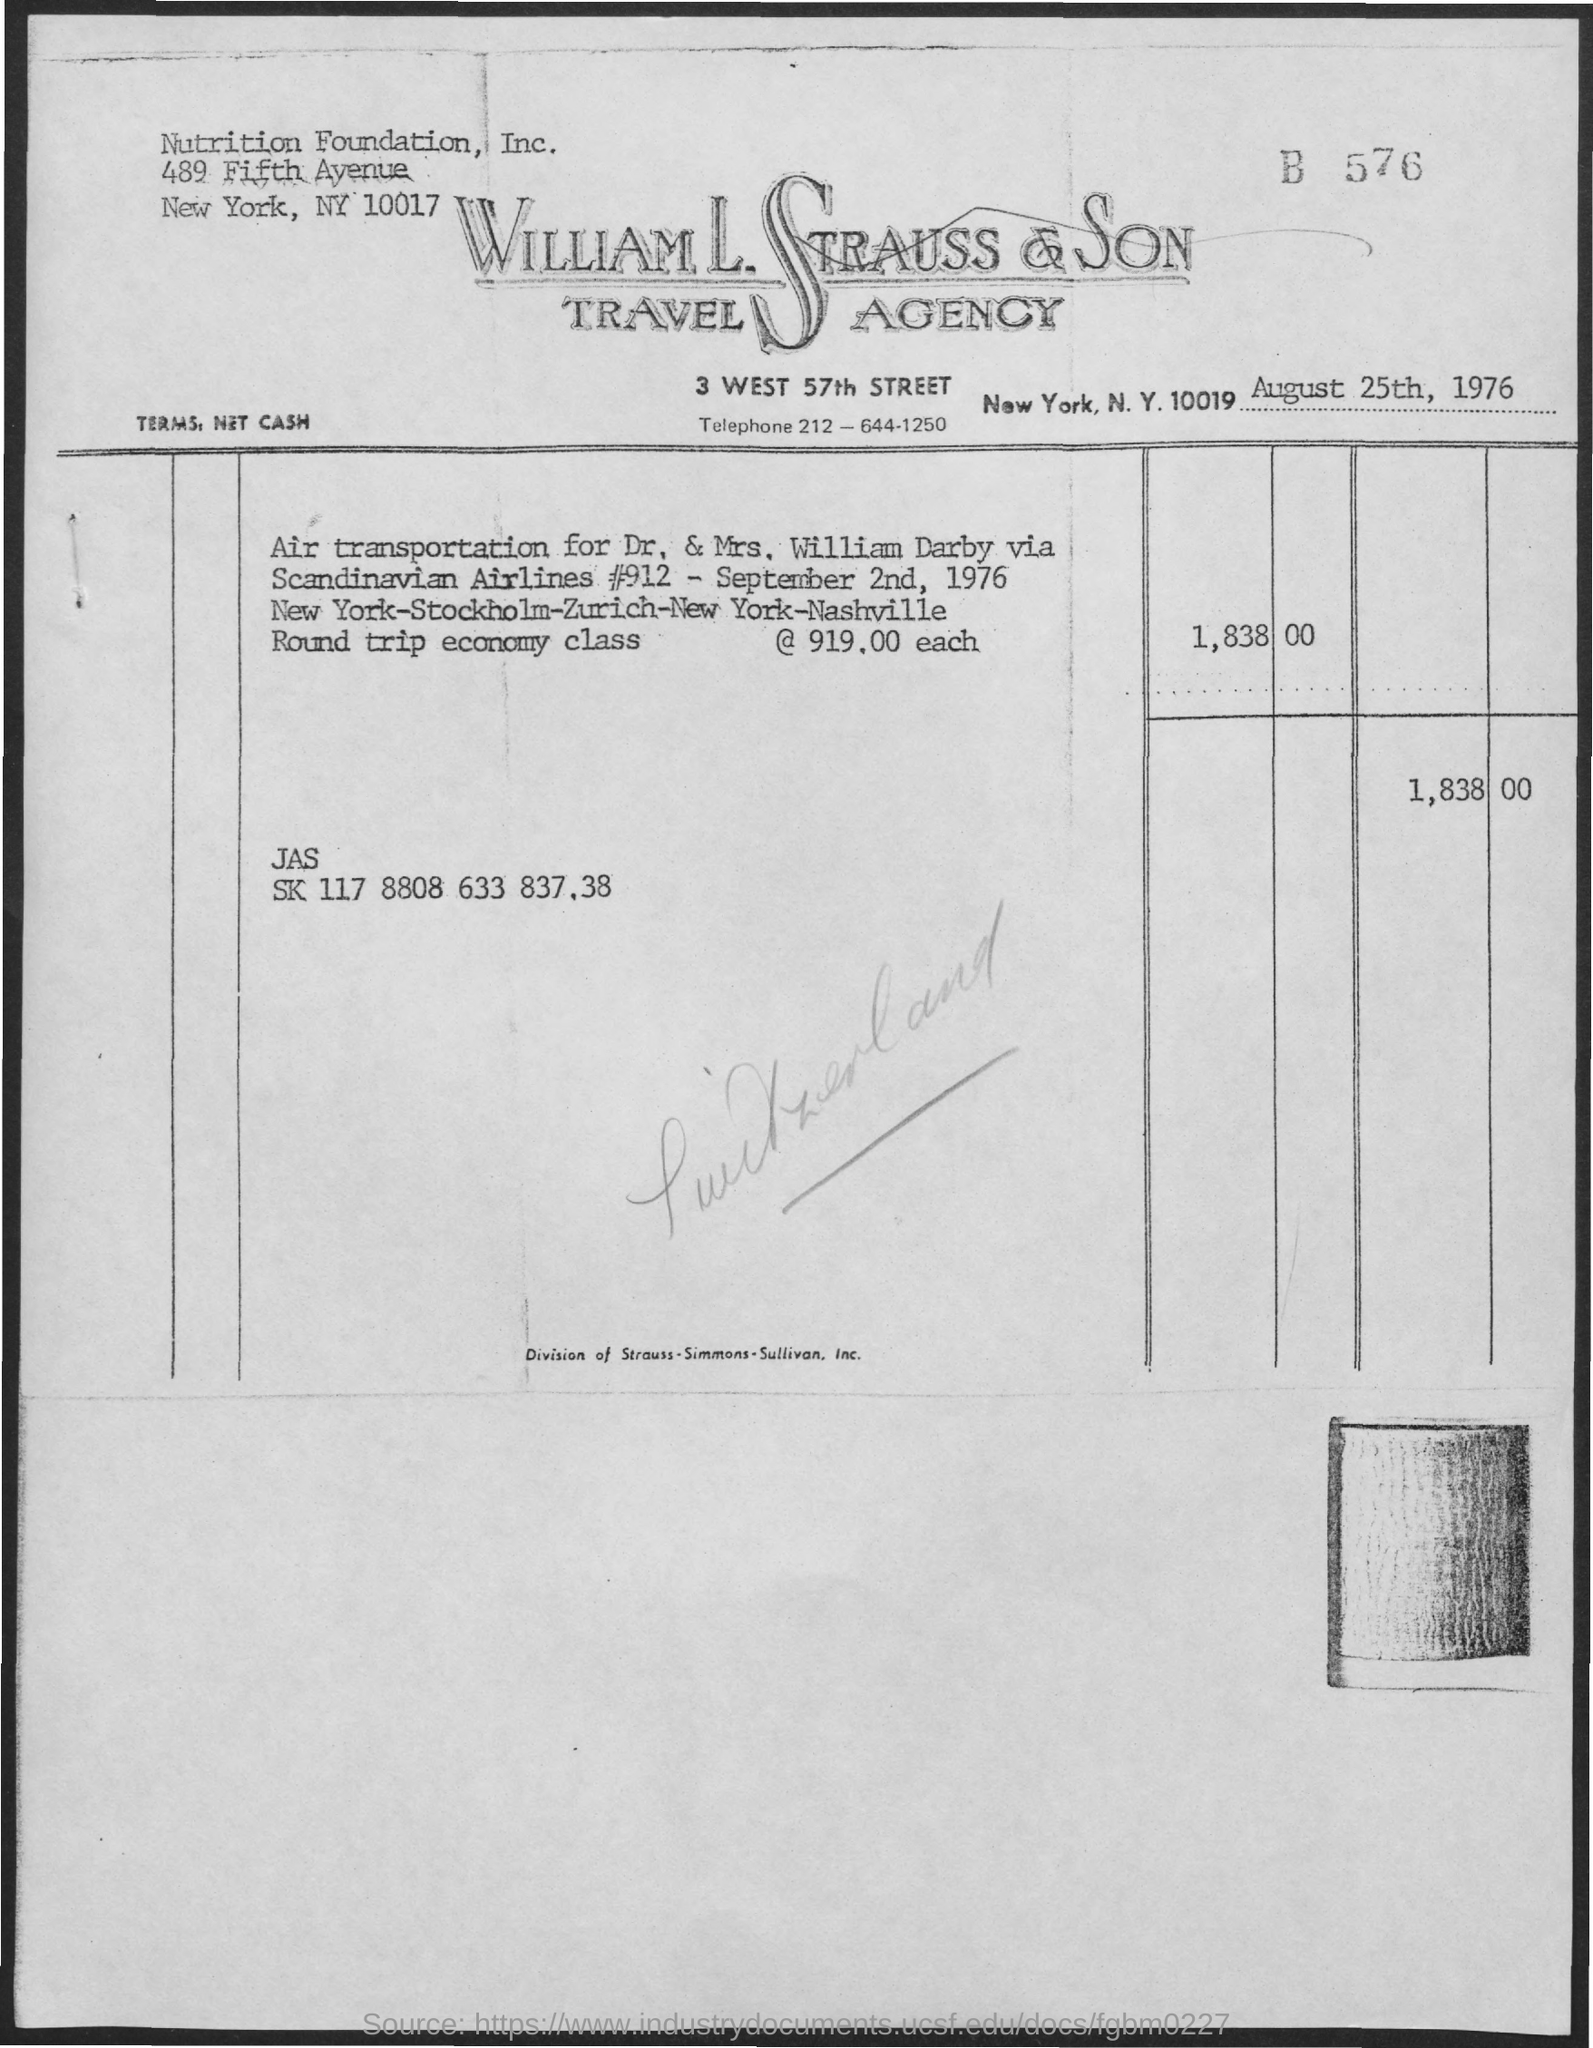What is the date on the document?
Offer a very short reply. August 25th, 1976. 